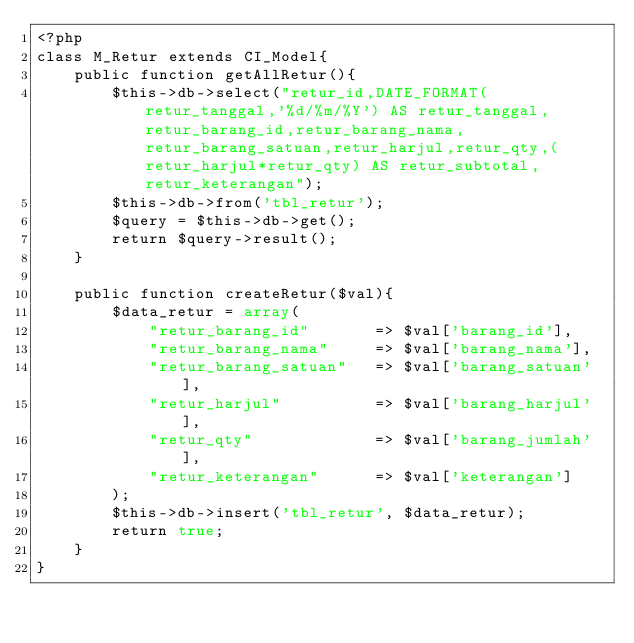<code> <loc_0><loc_0><loc_500><loc_500><_PHP_><?php
class M_Retur extends CI_Model{
	public function getAllRetur(){
		$this->db->select("retur_id,DATE_FORMAT(retur_tanggal,'%d/%m/%Y') AS retur_tanggal,retur_barang_id,retur_barang_nama,retur_barang_satuan,retur_harjul,retur_qty,(retur_harjul*retur_qty) AS retur_subtotal,retur_keterangan");
		$this->db->from('tbl_retur');
		$query = $this->db->get();
		return $query->result();
	}

	public function createRetur($val){
		$data_retur = array(
            "retur_barang_id" 		=> $val['barang_id'],
            "retur_barang_nama" 	=> $val['barang_nama'],
            "retur_barang_satuan"	=> $val['barang_satuan'],
            "retur_harjul" 			=> $val['barang_harjul'],
            "retur_qty" 		 	=> $val['barang_jumlah'],
            "retur_keterangan"		=> $val['keterangan']
        );
		$this->db->insert('tbl_retur', $data_retur);
		return true;
	}
}</code> 